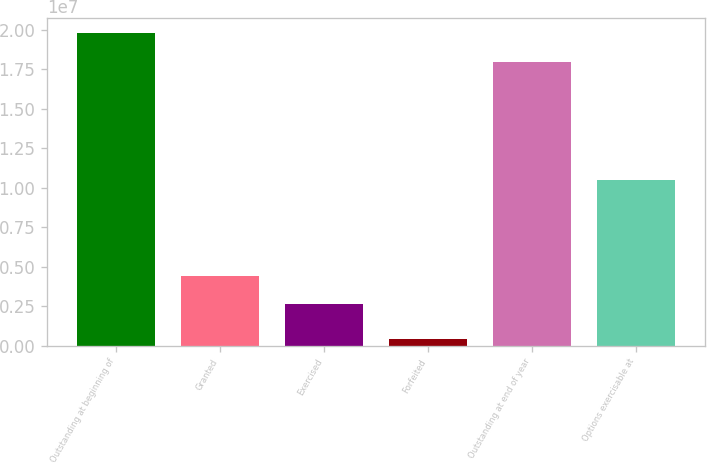Convert chart to OTSL. <chart><loc_0><loc_0><loc_500><loc_500><bar_chart><fcel>Outstanding at beginning of<fcel>Granted<fcel>Exercised<fcel>Forfeited<fcel>Outstanding at end of year<fcel>Options exercisable at<nl><fcel>1.97786e+07<fcel>4.42837e+06<fcel>2.64686e+06<fcel>415297<fcel>1.79971e+07<fcel>1.05071e+07<nl></chart> 